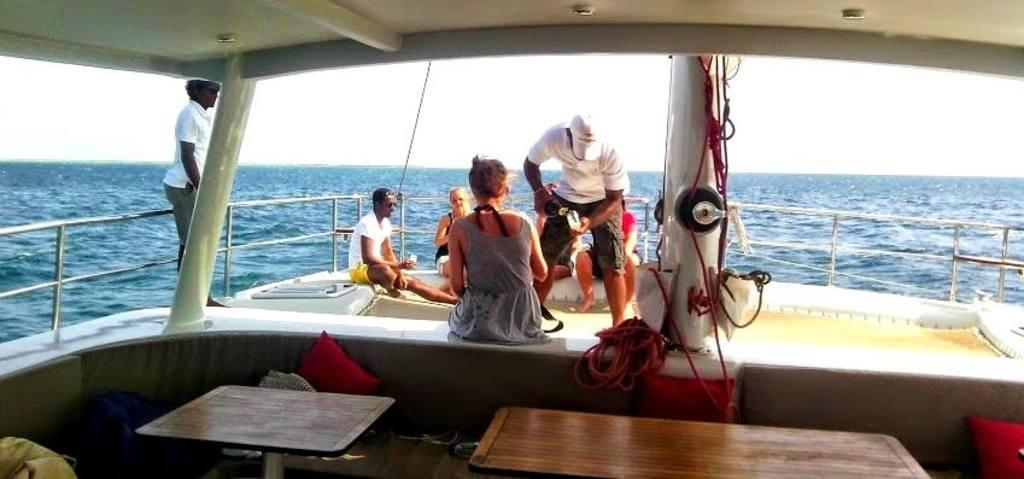What is the main subject of the image? The main subject of the image is a ship. What can be seen inside the ship? There is a group of people and tables inside the ship. What are the ropes used for in the ship? The ropes are likely used for various tasks related to sailing and maneuvering the ship. What is visible outside the ship? The sky and water are visible outside the ship. What type of book is being read by the people on the ship? There is no book visible in the image, and it is not mentioned that anyone is reading. 